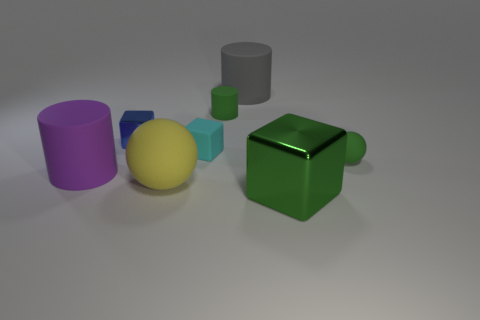Subtract all purple cylinders. How many cylinders are left? 2 Add 2 big purple matte cylinders. How many objects exist? 10 Subtract all tiny rubber cylinders. How many cylinders are left? 2 Subtract all cylinders. How many objects are left? 5 Subtract all yellow blocks. Subtract all cyan matte blocks. How many objects are left? 7 Add 6 tiny cubes. How many tiny cubes are left? 8 Add 1 green metallic cubes. How many green metallic cubes exist? 2 Subtract 1 green blocks. How many objects are left? 7 Subtract 3 cylinders. How many cylinders are left? 0 Subtract all blue spheres. Subtract all gray cylinders. How many spheres are left? 2 